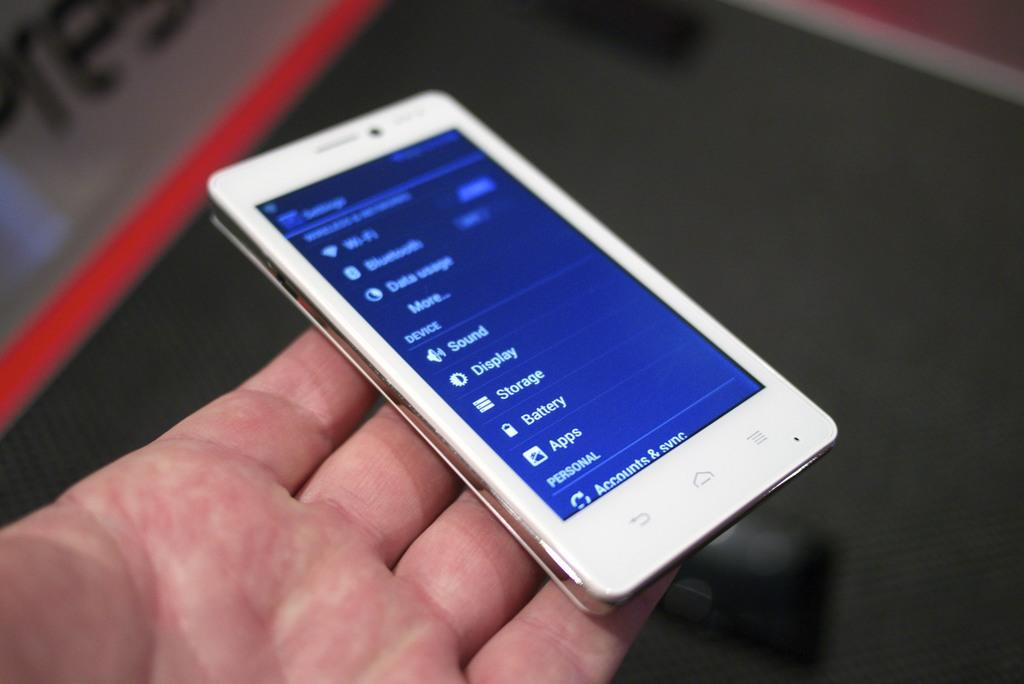<image>
Summarize the visual content of the image. the settings of a phone that has the word storage on it 